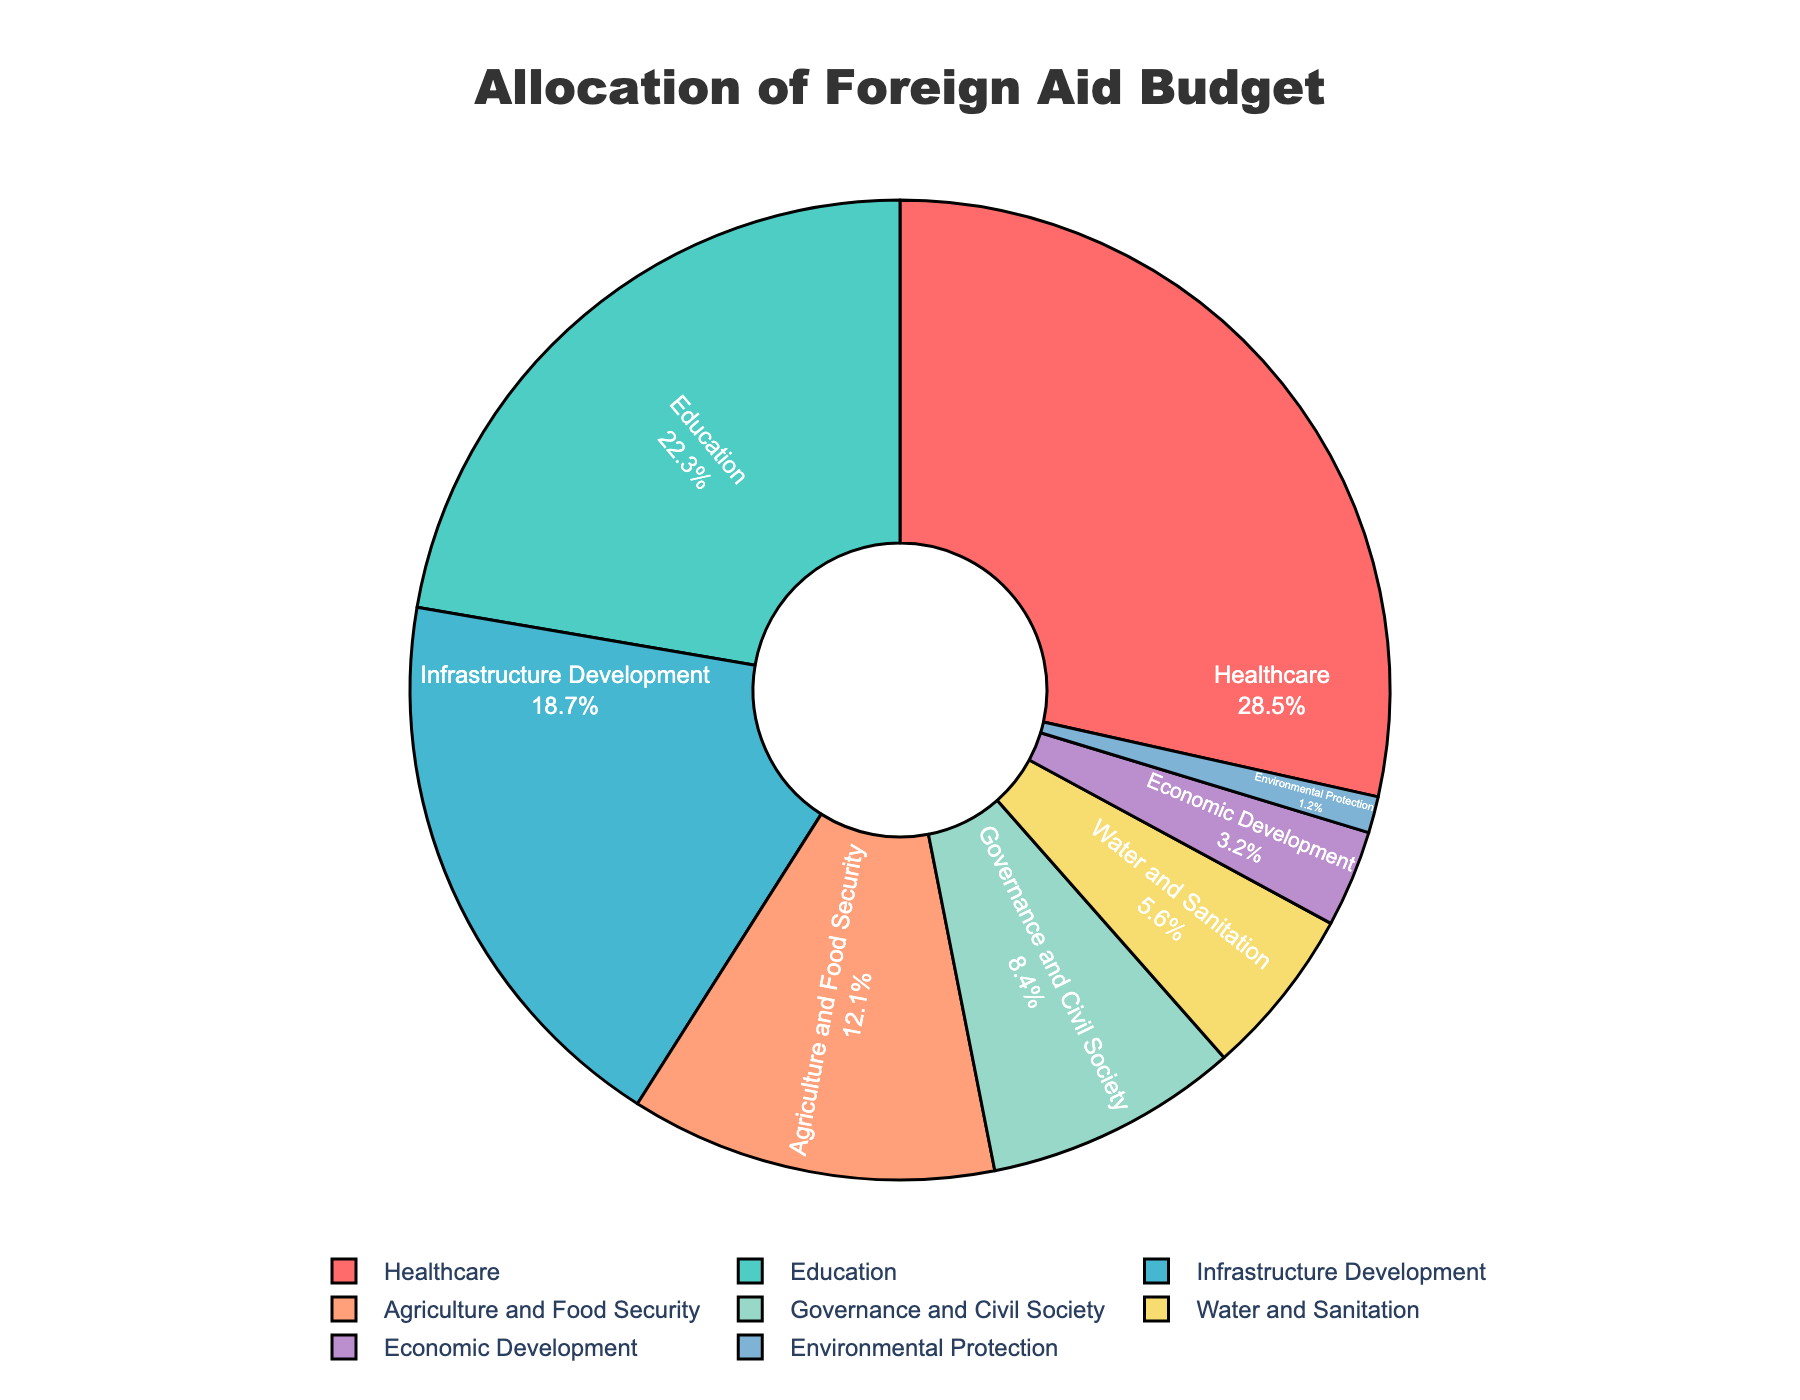What is the sector with the largest allocation of the foreign aid budget? To find the sector with the largest allocation, look at the percentage values in the pie chart and identify the one with the highest value. The Healthcare sector has the largest percentage of 28.5%.
Answer: Healthcare Which sector has the smallest allocation of the foreign aid budget? To determine the sector with the smallest allocation, check the percentage values and identify the one with the lowest value. The Environmental Protection sector has the smallest percentage of 1.2%.
Answer: Environmental Protection How much more percentage is allocated to Healthcare compared to Economic Development? Subtract the percentage of Economic Development from that of Healthcare to find the difference. Healthcare has 28.5% and Economic Development has 3.2%. Therefore, the difference is 28.5% - 3.2% which equals 25.3%.
Answer: 25.3% What is the combined percentage allocation for Education and Infrastructure Development? Add the percentages for Education and Infrastructure Development together. Education is 22.3% and Infrastructure Development is 18.7%. Adding these gives 22.3% + 18.7% = 41.0%.
Answer: 41.0% Is the percentage allocated to Governance and Civil Society greater than Water and Sanitation? Compare the percentage values of Governance and Civil Society (8.4%) and Water and Sanitation (5.6%). Since 8.4% is greater than 5.6%, the allocation for Governance and Civil Society is indeed greater.
Answer: Yes How does the allocation for Agriculture and Food Security compare to the average allocation of Education and Infrastructure Development? First, find the average allocation for Education and Infrastructure Development by adding their percentages and dividing by two. Education is 22.3% and Infrastructure Development is 18.7%, so their average is (22.3% + 18.7%) / 2 = 20.5%. Comparing Agriculture and Food Security's 12.1% to 20.5% shows that it is less.
Answer: Less Which sectors have an allocation percentage between 5% and 10%? Look for sectors whose percentages fall within the 5% to 10% range. Governance and Civil Society (8.4%) and Water and Sanitation (5.6%) fall in this range.
Answer: Governance and Civil Society, Water and Sanitation How much percentage is allocated to the combination of sectors with single-digit percentages? Add the percentages of sectors with less than 10%. Governance and Civil Society, Water and Sanitation, Economic Development, and Environmental Protection have percentages of 8.4%, 5.6%, 3.2%, and 1.2%, respectively. Summing these gives 8.4% + 5.6% + 3.2% + 1.2% = 18.4%.
Answer: 18.4% What proportion of the foreign aid budget goes to the top three sectors? Combine the percentages of the top three sectors Healthcare, Education, and Infrastructure Development. Their values are 28.5%, 22.3%, and 18.7%, respectively. Adding these gives 28.5% + 22.3% + 18.7% = 69.5%.
Answer: 69.5% If the budget for Water and Sanitation was doubled, what would its new percentage be? To find the new percentage, multiply the current percentage of Water and Sanitation (5.6%) by 2. The new percentage would be 5.6% * 2 = 11.2%.
Answer: 11.2% 